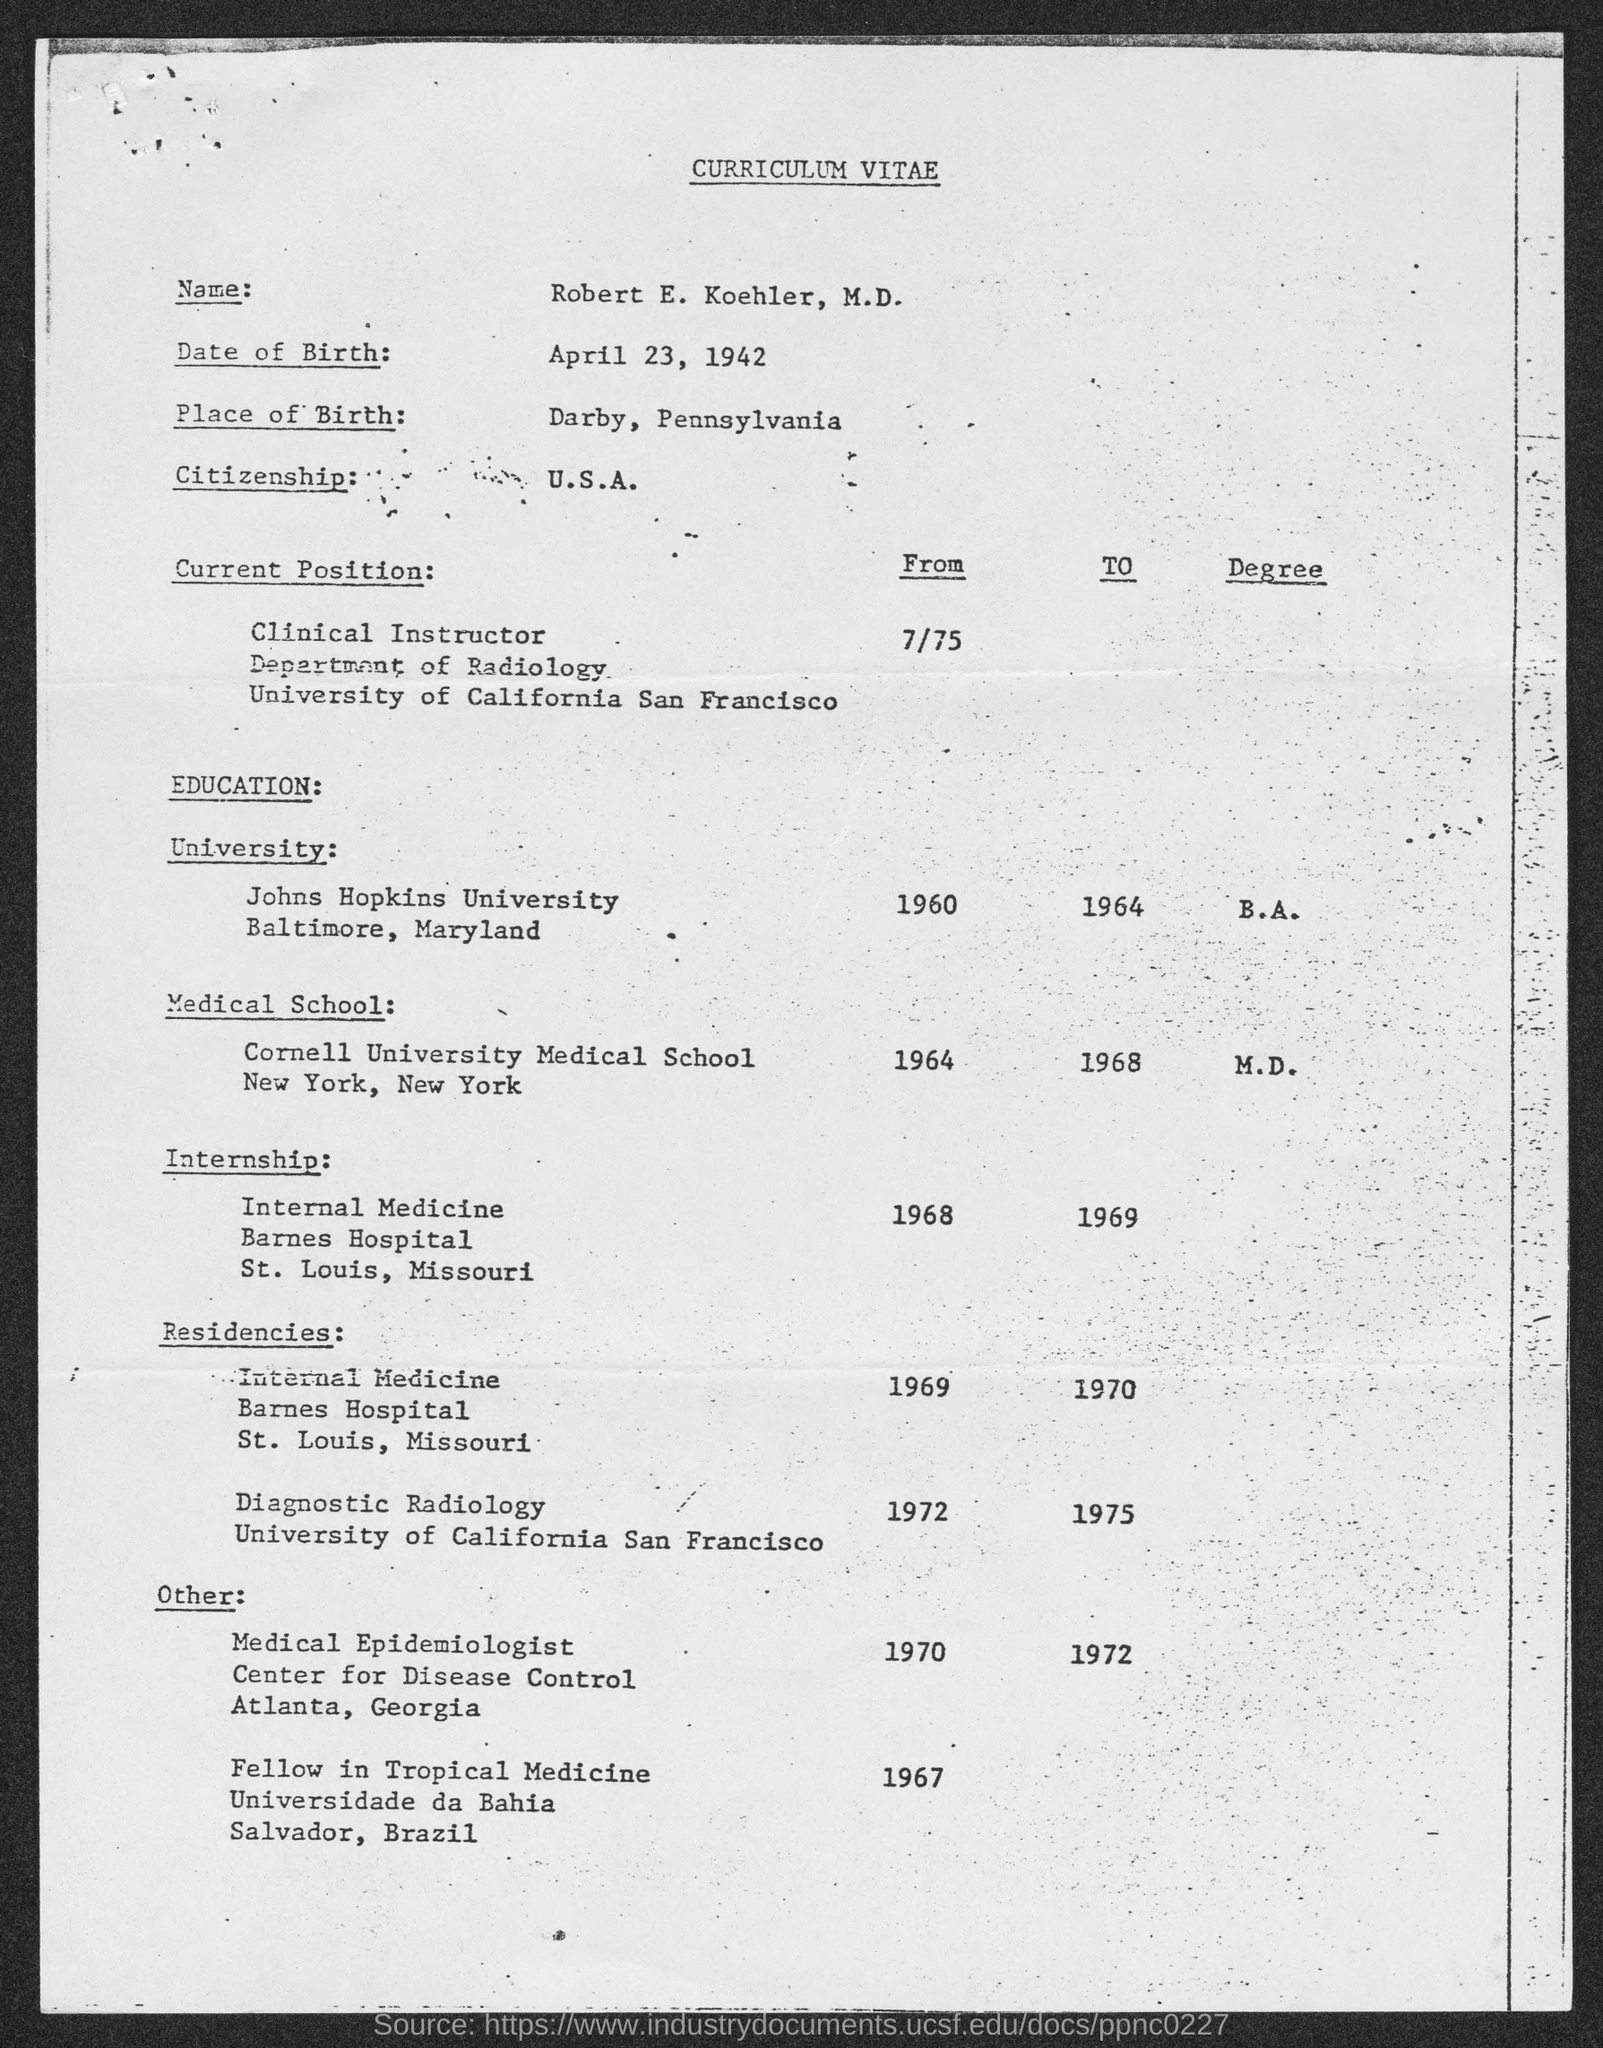Specify some key components in this picture. Robert E. Koehler, M.D. completed his M.D. degree from Cornell University Medical School in 1968. Robert E. Koehler, M.D. was born in Darby, Pennsylvania. Robert E. Koehler, M.D. was born on April 23, 1942. Robert E. Koehler, M.D., is a United States citizen. Robert E. Koehler, M.D. completed his B.A. degree at Johns Hopkins University. 